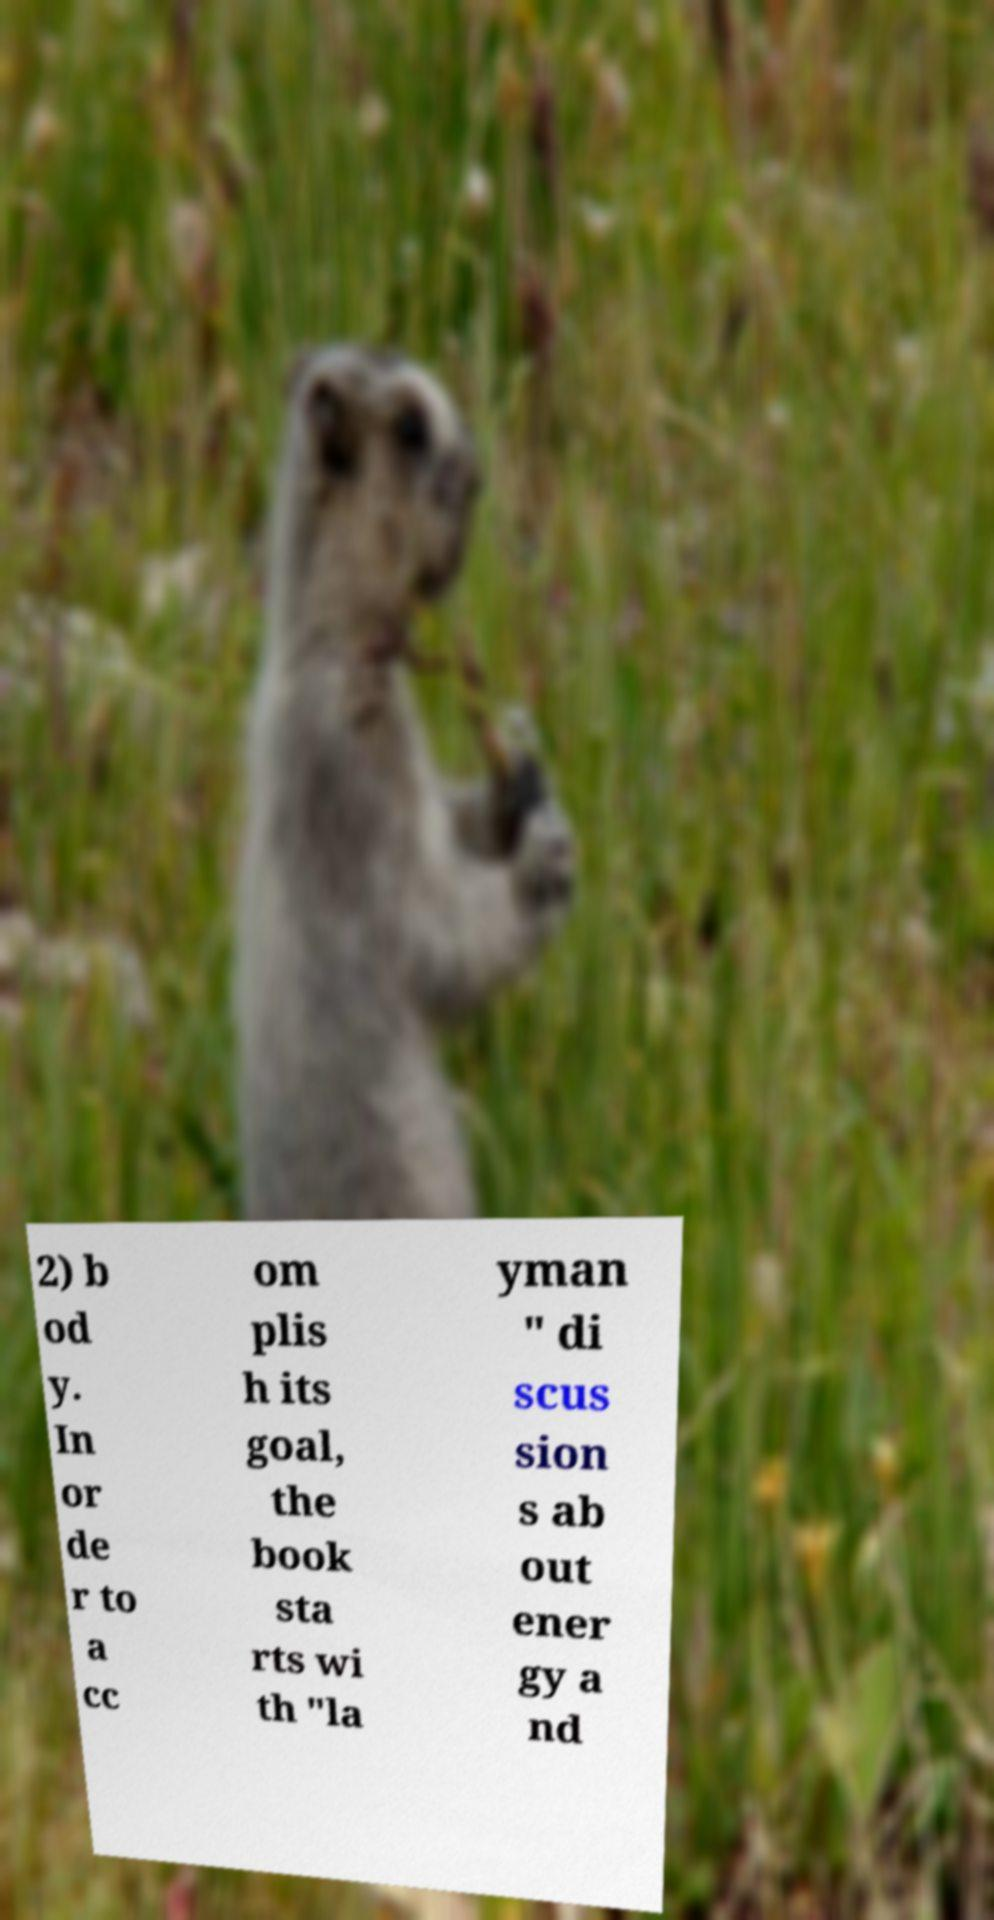Please read and relay the text visible in this image. What does it say? 2) b od y. In or de r to a cc om plis h its goal, the book sta rts wi th "la yman " di scus sion s ab out ener gy a nd 